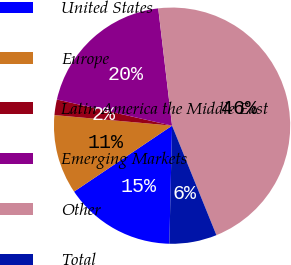<chart> <loc_0><loc_0><loc_500><loc_500><pie_chart><fcel>United States<fcel>Europe<fcel>Latin America the Middle East<fcel>Emerging Markets<fcel>Other<fcel>Total<nl><fcel>15.21%<fcel>10.85%<fcel>2.13%<fcel>19.57%<fcel>45.74%<fcel>6.49%<nl></chart> 